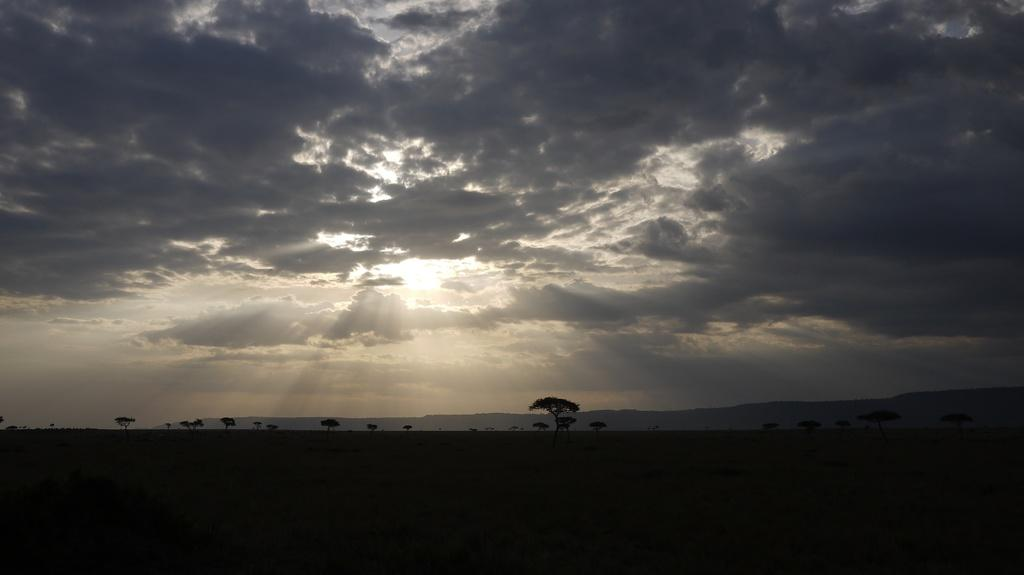What type of vegetation can be seen in the image? There are trees in the image. What geographical features are present in the image? There are hills in the image. What is visible in the sky in the image? The sky is visible in the image. What can be observed in the sky in the image? Clouds are present in the sky. What type of drink is being served on the hill in the image? There is no drink or any indication of a drink being served in the image. The image only features trees, hills, and clouds in the sky. 